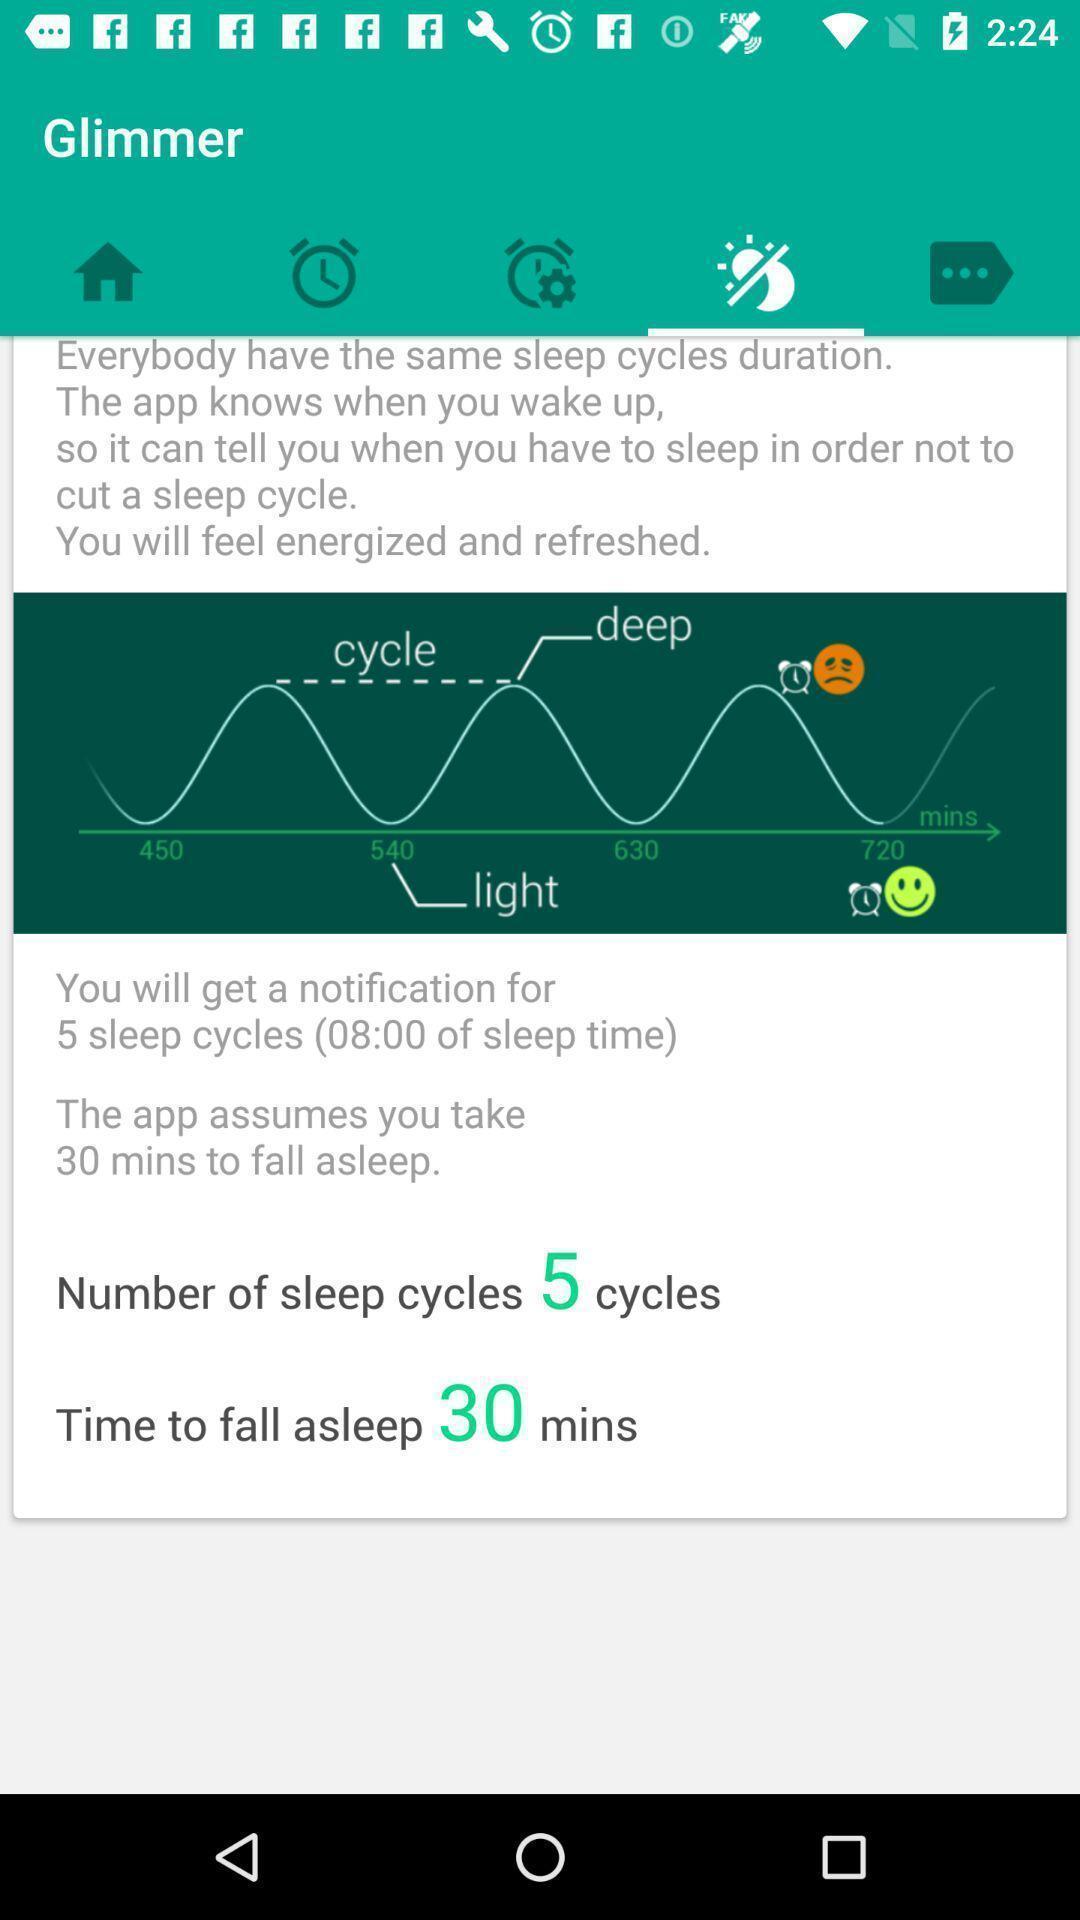Provide a textual representation of this image. Sleep page in a lifestyle app. 